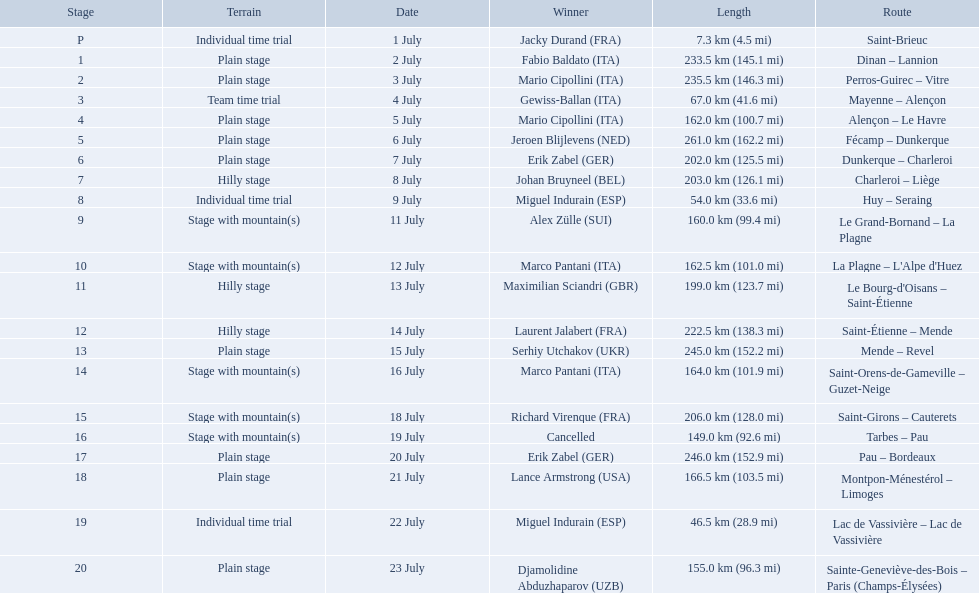What were the dates of the 1995 tour de france? 1 July, 2 July, 3 July, 4 July, 5 July, 6 July, 7 July, 8 July, 9 July, 11 July, 12 July, 13 July, 14 July, 15 July, 16 July, 18 July, 19 July, 20 July, 21 July, 22 July, 23 July. What was the length for july 8th? 203.0 km (126.1 mi). 